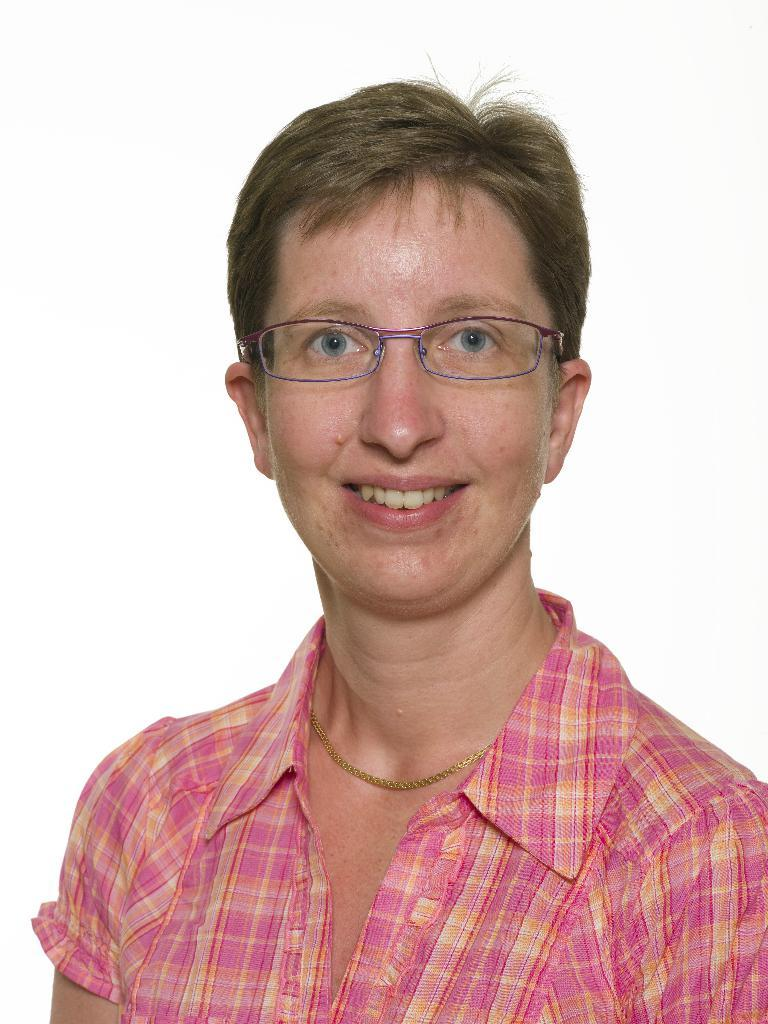What color is the shirt worn by the woman in the image? The woman in the image is wearing a pink shirt. What accessory is the woman wearing on her face? The woman is wearing spectacles. What expression does the woman have in the image? The woman is smiling. Can you describe the woman's posture or pose in the image? The woman might be posing for the photo. What is the color of the background in the image? The background of the image is white in color. What type of shoes is the woman wearing in the image? There is no information about shoes in the image, as the focus is on the woman's shirt, spectacles, and smile. 